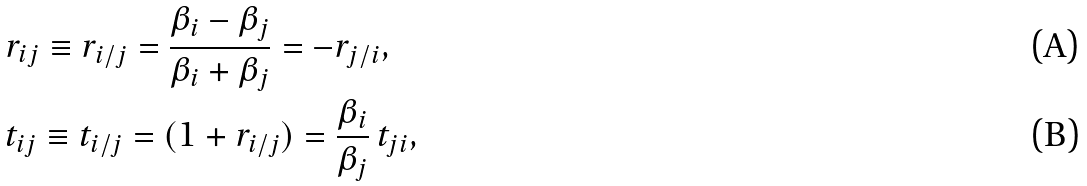Convert formula to latex. <formula><loc_0><loc_0><loc_500><loc_500>& r _ { i j } \equiv r _ { i / j } = \frac { \beta _ { i } - \beta _ { j } } { \beta _ { i } + \beta _ { j } } = - r _ { j / i } , \\ & t _ { i j } \equiv t _ { i / j } = ( 1 + r _ { i / j } ) = \frac { \beta _ { i } } { \beta _ { j } } \, t _ { j i } ,</formula> 